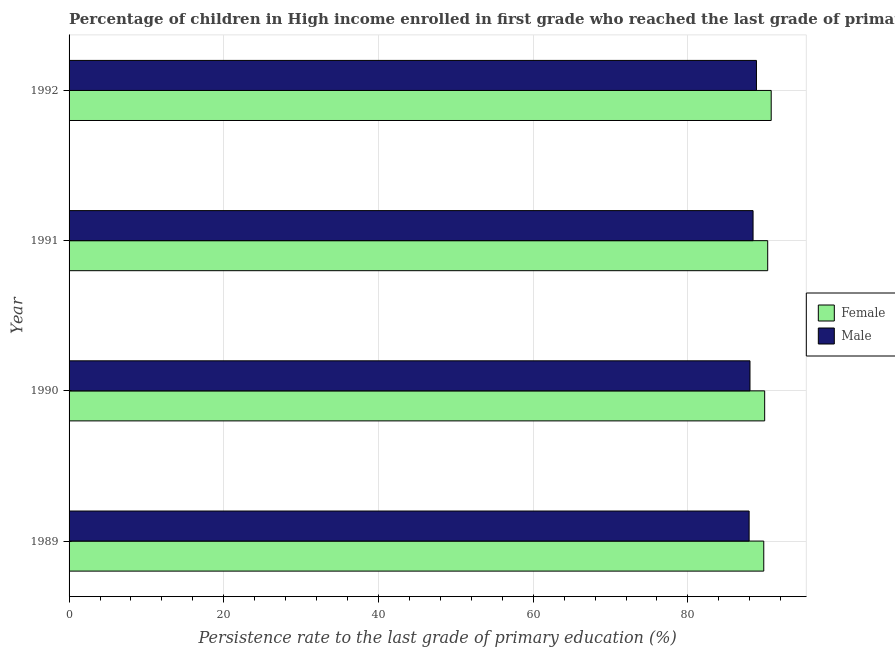How many different coloured bars are there?
Ensure brevity in your answer.  2. How many groups of bars are there?
Offer a terse response. 4. Are the number of bars per tick equal to the number of legend labels?
Your answer should be compact. Yes. What is the label of the 1st group of bars from the top?
Give a very brief answer. 1992. What is the persistence rate of male students in 1991?
Offer a terse response. 88.42. Across all years, what is the maximum persistence rate of male students?
Your answer should be very brief. 88.86. Across all years, what is the minimum persistence rate of female students?
Your answer should be compact. 89.81. In which year was the persistence rate of male students minimum?
Your answer should be compact. 1989. What is the total persistence rate of male students in the graph?
Your answer should be compact. 353.23. What is the difference between the persistence rate of male students in 1990 and that in 1992?
Keep it short and to the point. -0.83. What is the difference between the persistence rate of female students in 1989 and the persistence rate of male students in 1991?
Ensure brevity in your answer.  1.38. What is the average persistence rate of female students per year?
Keep it short and to the point. 90.2. In the year 1989, what is the difference between the persistence rate of female students and persistence rate of male students?
Ensure brevity in your answer.  1.89. What is the ratio of the persistence rate of male students in 1989 to that in 1991?
Offer a very short reply. 0.99. What is the difference between the highest and the second highest persistence rate of female students?
Provide a short and direct response. 0.45. What is the difference between the highest and the lowest persistence rate of male students?
Provide a short and direct response. 0.95. In how many years, is the persistence rate of female students greater than the average persistence rate of female students taken over all years?
Your response must be concise. 2. What does the 2nd bar from the top in 1991 represents?
Make the answer very short. Female. How many years are there in the graph?
Your response must be concise. 4. Does the graph contain any zero values?
Make the answer very short. No. Does the graph contain grids?
Your response must be concise. Yes. How many legend labels are there?
Ensure brevity in your answer.  2. What is the title of the graph?
Offer a very short reply. Percentage of children in High income enrolled in first grade who reached the last grade of primary education. What is the label or title of the X-axis?
Provide a succinct answer. Persistence rate to the last grade of primary education (%). What is the label or title of the Y-axis?
Your answer should be compact. Year. What is the Persistence rate to the last grade of primary education (%) in Female in 1989?
Your answer should be compact. 89.81. What is the Persistence rate to the last grade of primary education (%) in Male in 1989?
Provide a short and direct response. 87.92. What is the Persistence rate to the last grade of primary education (%) in Female in 1990?
Provide a succinct answer. 89.93. What is the Persistence rate to the last grade of primary education (%) in Male in 1990?
Your answer should be compact. 88.03. What is the Persistence rate to the last grade of primary education (%) in Female in 1991?
Keep it short and to the point. 90.32. What is the Persistence rate to the last grade of primary education (%) in Male in 1991?
Your answer should be very brief. 88.42. What is the Persistence rate to the last grade of primary education (%) of Female in 1992?
Ensure brevity in your answer.  90.77. What is the Persistence rate to the last grade of primary education (%) in Male in 1992?
Provide a succinct answer. 88.86. Across all years, what is the maximum Persistence rate to the last grade of primary education (%) in Female?
Give a very brief answer. 90.77. Across all years, what is the maximum Persistence rate to the last grade of primary education (%) in Male?
Your answer should be very brief. 88.86. Across all years, what is the minimum Persistence rate to the last grade of primary education (%) of Female?
Your answer should be very brief. 89.81. Across all years, what is the minimum Persistence rate to the last grade of primary education (%) of Male?
Provide a short and direct response. 87.92. What is the total Persistence rate to the last grade of primary education (%) of Female in the graph?
Your answer should be very brief. 360.82. What is the total Persistence rate to the last grade of primary education (%) in Male in the graph?
Offer a very short reply. 353.23. What is the difference between the Persistence rate to the last grade of primary education (%) of Female in 1989 and that in 1990?
Offer a terse response. -0.12. What is the difference between the Persistence rate to the last grade of primary education (%) in Male in 1989 and that in 1990?
Offer a very short reply. -0.11. What is the difference between the Persistence rate to the last grade of primary education (%) of Female in 1989 and that in 1991?
Provide a succinct answer. -0.51. What is the difference between the Persistence rate to the last grade of primary education (%) of Male in 1989 and that in 1991?
Your answer should be very brief. -0.51. What is the difference between the Persistence rate to the last grade of primary education (%) of Female in 1989 and that in 1992?
Offer a very short reply. -0.96. What is the difference between the Persistence rate to the last grade of primary education (%) of Male in 1989 and that in 1992?
Provide a short and direct response. -0.95. What is the difference between the Persistence rate to the last grade of primary education (%) in Female in 1990 and that in 1991?
Make the answer very short. -0.39. What is the difference between the Persistence rate to the last grade of primary education (%) of Male in 1990 and that in 1991?
Offer a very short reply. -0.4. What is the difference between the Persistence rate to the last grade of primary education (%) in Female in 1990 and that in 1992?
Offer a very short reply. -0.84. What is the difference between the Persistence rate to the last grade of primary education (%) of Male in 1990 and that in 1992?
Make the answer very short. -0.84. What is the difference between the Persistence rate to the last grade of primary education (%) in Female in 1991 and that in 1992?
Offer a terse response. -0.45. What is the difference between the Persistence rate to the last grade of primary education (%) of Male in 1991 and that in 1992?
Offer a terse response. -0.44. What is the difference between the Persistence rate to the last grade of primary education (%) in Female in 1989 and the Persistence rate to the last grade of primary education (%) in Male in 1990?
Offer a terse response. 1.78. What is the difference between the Persistence rate to the last grade of primary education (%) in Female in 1989 and the Persistence rate to the last grade of primary education (%) in Male in 1991?
Your response must be concise. 1.38. What is the difference between the Persistence rate to the last grade of primary education (%) in Female in 1989 and the Persistence rate to the last grade of primary education (%) in Male in 1992?
Give a very brief answer. 0.95. What is the difference between the Persistence rate to the last grade of primary education (%) of Female in 1990 and the Persistence rate to the last grade of primary education (%) of Male in 1991?
Ensure brevity in your answer.  1.5. What is the difference between the Persistence rate to the last grade of primary education (%) in Female in 1990 and the Persistence rate to the last grade of primary education (%) in Male in 1992?
Your answer should be very brief. 1.06. What is the difference between the Persistence rate to the last grade of primary education (%) in Female in 1991 and the Persistence rate to the last grade of primary education (%) in Male in 1992?
Provide a short and direct response. 1.45. What is the average Persistence rate to the last grade of primary education (%) in Female per year?
Provide a succinct answer. 90.21. What is the average Persistence rate to the last grade of primary education (%) of Male per year?
Make the answer very short. 88.31. In the year 1989, what is the difference between the Persistence rate to the last grade of primary education (%) in Female and Persistence rate to the last grade of primary education (%) in Male?
Your answer should be very brief. 1.89. In the year 1990, what is the difference between the Persistence rate to the last grade of primary education (%) in Female and Persistence rate to the last grade of primary education (%) in Male?
Ensure brevity in your answer.  1.9. In the year 1991, what is the difference between the Persistence rate to the last grade of primary education (%) in Female and Persistence rate to the last grade of primary education (%) in Male?
Offer a very short reply. 1.89. In the year 1992, what is the difference between the Persistence rate to the last grade of primary education (%) in Female and Persistence rate to the last grade of primary education (%) in Male?
Offer a terse response. 1.91. What is the ratio of the Persistence rate to the last grade of primary education (%) in Female in 1989 to that in 1990?
Your answer should be very brief. 1. What is the ratio of the Persistence rate to the last grade of primary education (%) in Male in 1989 to that in 1990?
Keep it short and to the point. 1. What is the ratio of the Persistence rate to the last grade of primary education (%) of Female in 1989 to that in 1991?
Your response must be concise. 0.99. What is the ratio of the Persistence rate to the last grade of primary education (%) in Male in 1989 to that in 1991?
Provide a succinct answer. 0.99. What is the ratio of the Persistence rate to the last grade of primary education (%) of Male in 1989 to that in 1992?
Offer a very short reply. 0.99. What is the ratio of the Persistence rate to the last grade of primary education (%) in Male in 1990 to that in 1991?
Make the answer very short. 1. What is the ratio of the Persistence rate to the last grade of primary education (%) in Male in 1990 to that in 1992?
Provide a succinct answer. 0.99. What is the ratio of the Persistence rate to the last grade of primary education (%) in Female in 1991 to that in 1992?
Your response must be concise. 0.99. What is the difference between the highest and the second highest Persistence rate to the last grade of primary education (%) in Female?
Make the answer very short. 0.45. What is the difference between the highest and the second highest Persistence rate to the last grade of primary education (%) of Male?
Your answer should be very brief. 0.44. What is the difference between the highest and the lowest Persistence rate to the last grade of primary education (%) in Female?
Your answer should be compact. 0.96. What is the difference between the highest and the lowest Persistence rate to the last grade of primary education (%) in Male?
Your response must be concise. 0.95. 